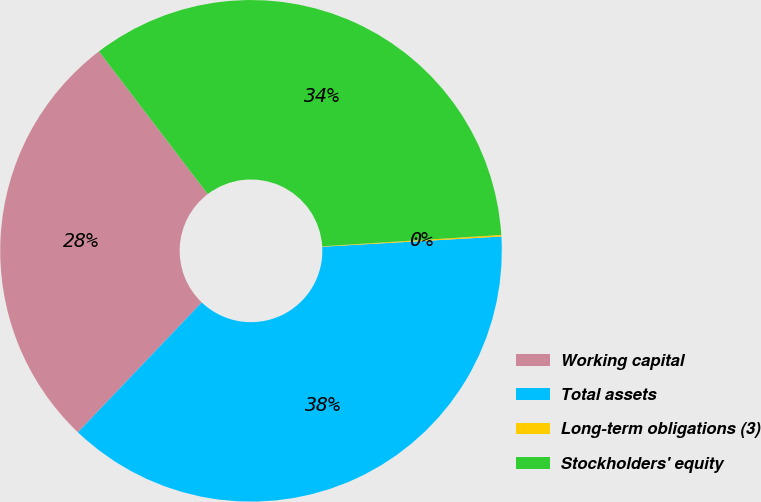<chart> <loc_0><loc_0><loc_500><loc_500><pie_chart><fcel>Working capital<fcel>Total assets<fcel>Long-term obligations (3)<fcel>Stockholders' equity<nl><fcel>27.51%<fcel>38.03%<fcel>0.1%<fcel>34.36%<nl></chart> 